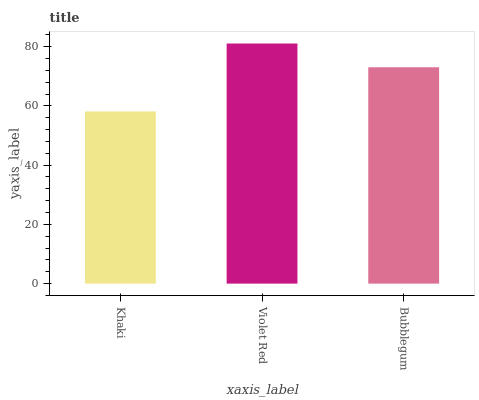Is Bubblegum the minimum?
Answer yes or no. No. Is Bubblegum the maximum?
Answer yes or no. No. Is Violet Red greater than Bubblegum?
Answer yes or no. Yes. Is Bubblegum less than Violet Red?
Answer yes or no. Yes. Is Bubblegum greater than Violet Red?
Answer yes or no. No. Is Violet Red less than Bubblegum?
Answer yes or no. No. Is Bubblegum the high median?
Answer yes or no. Yes. Is Bubblegum the low median?
Answer yes or no. Yes. Is Khaki the high median?
Answer yes or no. No. Is Khaki the low median?
Answer yes or no. No. 